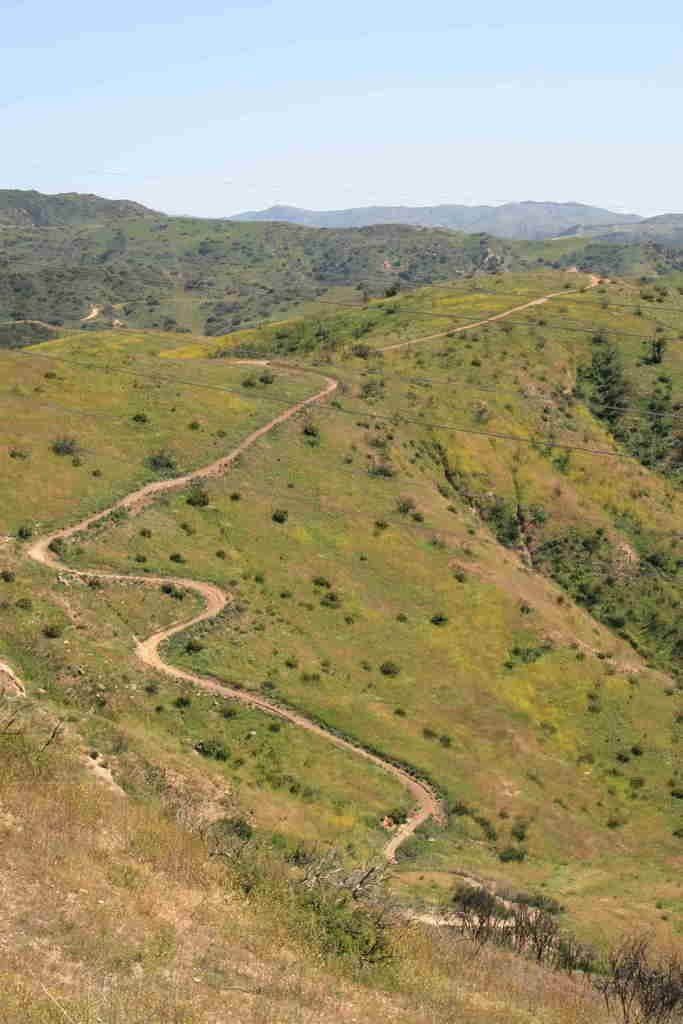What type of vegetation can be seen in the image? There are trees in the image. What color are the trees in the image? The trees are green in color. What is visible in the background of the image? The sky is visible in the background of the image. What colors can be seen in the sky in the image? The sky is blue and white in color. How many bikes are parked under the trees in the image? There are no bikes present in the image; it only features trees and a blue and white sky. 